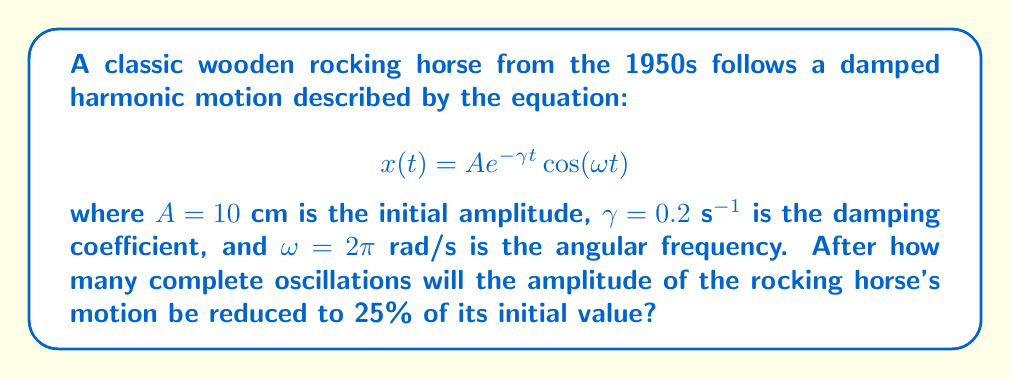Can you answer this question? To solve this problem, we'll follow these steps:

1) The amplitude of the oscillation at time $t$ is given by $Ae^{-\gamma t}$.

2) We want to find when this amplitude is 25% of the initial amplitude:

   $$Ae^{-\gamma t} = 0.25A$$

3) Dividing both sides by $A$:

   $$e^{-\gamma t} = 0.25$$

4) Taking the natural logarithm of both sides:

   $$-\gamma t = \ln(0.25)$$

5) Solving for $t$:

   $$t = -\frac{\ln(0.25)}{\gamma} = -\frac{\ln(0.25)}{0.2} \approx 6.93 \text{ s}$$

6) To find the number of oscillations, we need to divide this time by the period of one oscillation. The period $T$ is given by:

   $$T = \frac{2\pi}{\omega} = \frac{2\pi}{2\pi} = 1 \text{ s}$$

7) The number of oscillations is:

   $$\text{Number of oscillations} = \frac{t}{T} = \frac{6.93}{1} \approx 6.93$$

8) Since we're asked for complete oscillations, we round down to 6.
Answer: 6 oscillations 